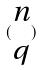<formula> <loc_0><loc_0><loc_500><loc_500>( \begin{matrix} n \\ q \end{matrix} )</formula> 